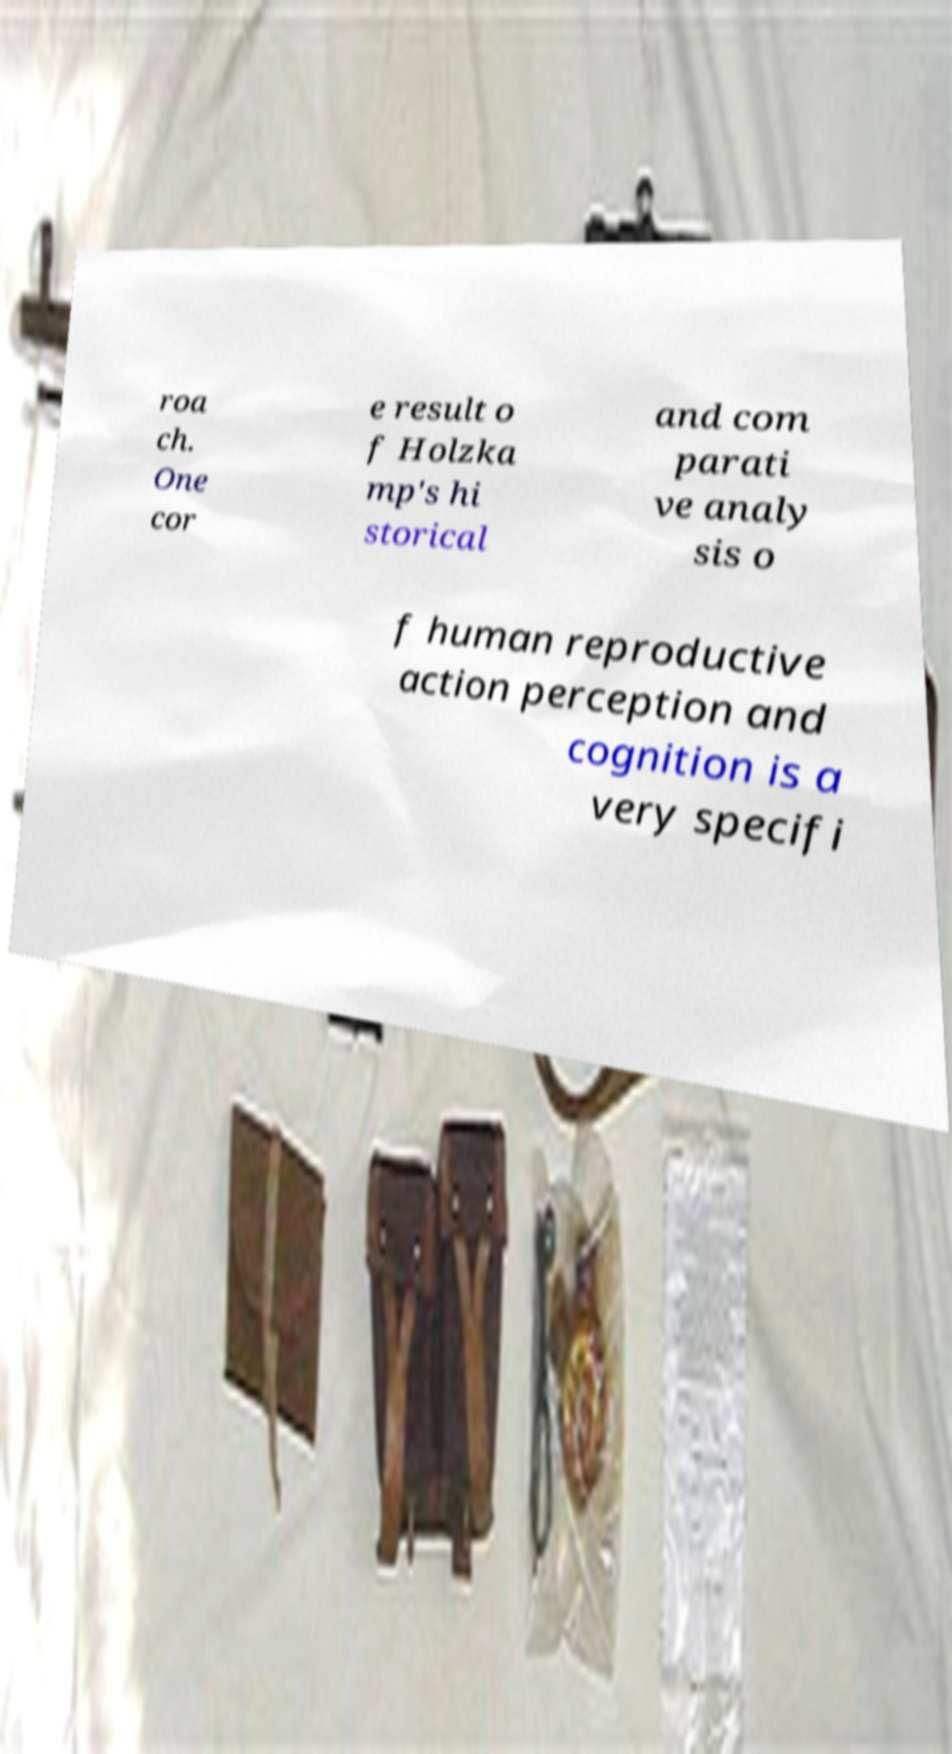Can you read and provide the text displayed in the image?This photo seems to have some interesting text. Can you extract and type it out for me? roa ch. One cor e result o f Holzka mp's hi storical and com parati ve analy sis o f human reproductive action perception and cognition is a very specifi 